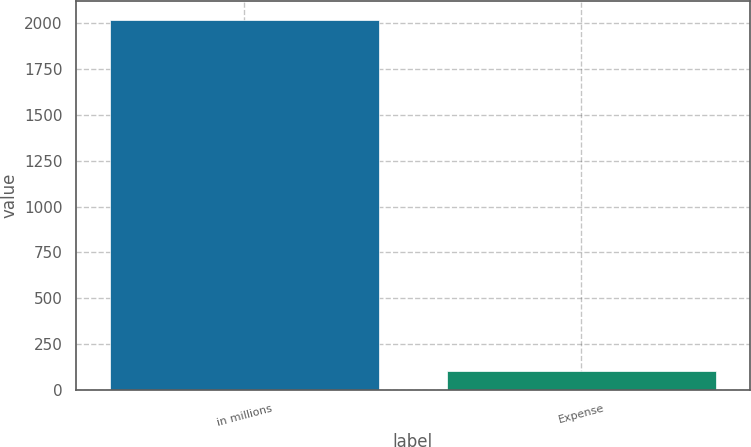Convert chart. <chart><loc_0><loc_0><loc_500><loc_500><bar_chart><fcel>in millions<fcel>Expense<nl><fcel>2017<fcel>106<nl></chart> 